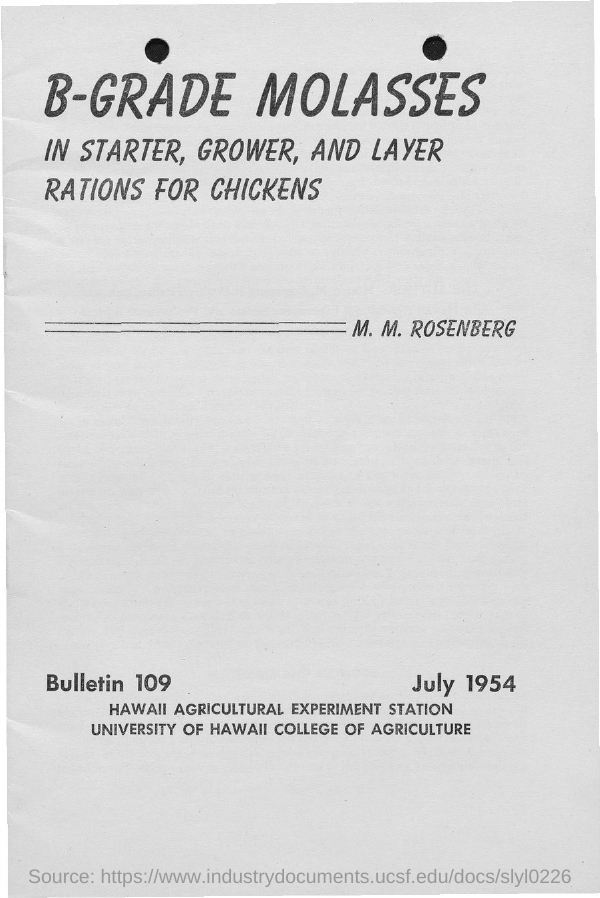Give some essential details in this illustration. Please provide the bulletin number, 109... The document mentions a date of July 1954. The first title in the document is 'B-grade molasses,' 